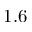<formula> <loc_0><loc_0><loc_500><loc_500>1 . 6</formula> 